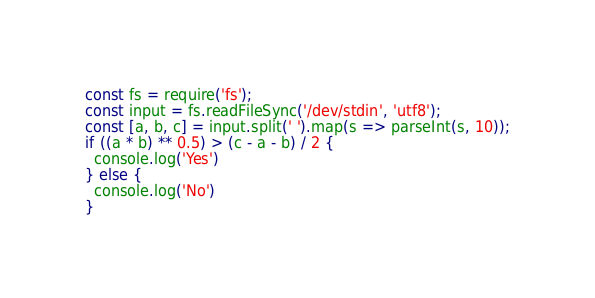Convert code to text. <code><loc_0><loc_0><loc_500><loc_500><_TypeScript_>const fs = require('fs');
const input = fs.readFileSync('/dev/stdin', 'utf8');
const [a, b, c] = input.split(' ').map(s => parseInt(s, 10));
if ((a * b) ** 0.5) > (c - a - b) / 2 {
  console.log('Yes')
} else {
  console.log('No')
}</code> 